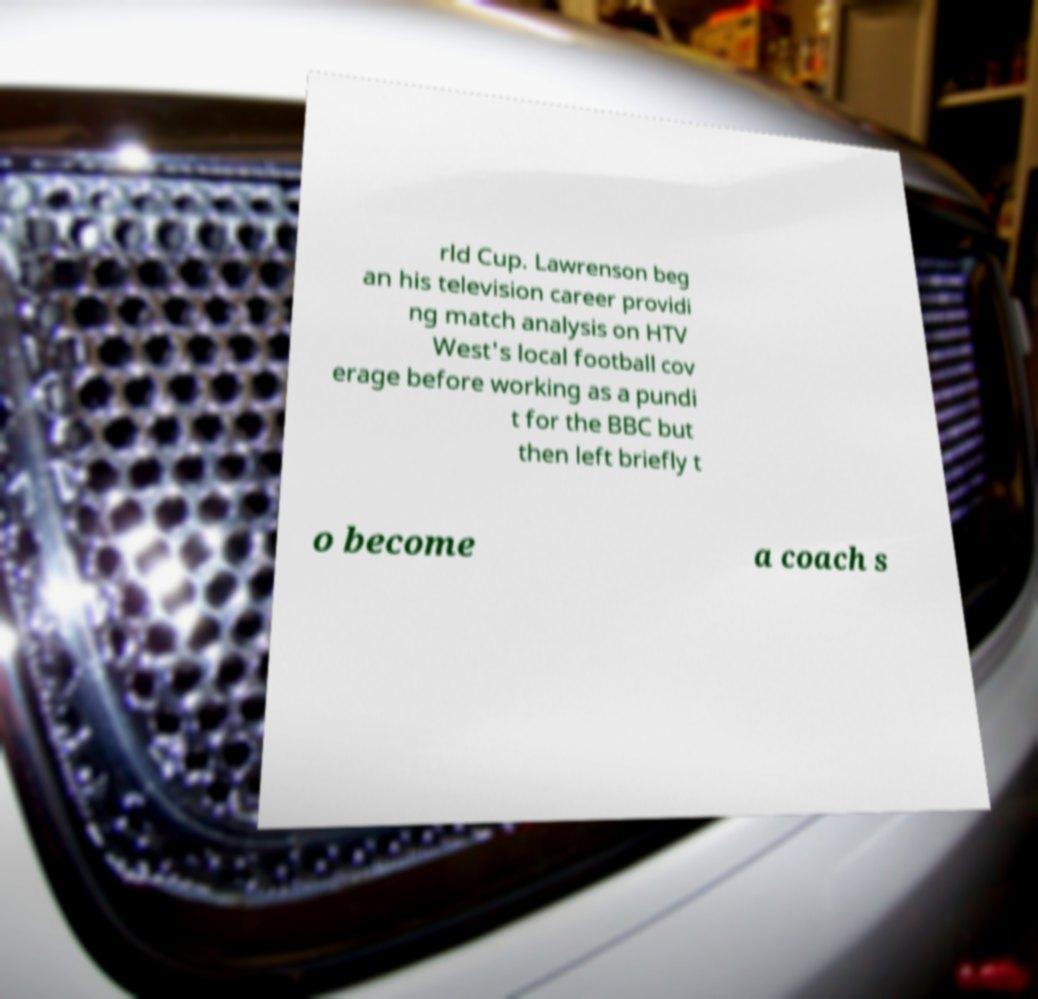I need the written content from this picture converted into text. Can you do that? rld Cup. Lawrenson beg an his television career providi ng match analysis on HTV West's local football cov erage before working as a pundi t for the BBC but then left briefly t o become a coach s 